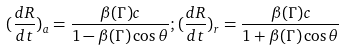Convert formula to latex. <formula><loc_0><loc_0><loc_500><loc_500>( \frac { d R } { d t } ) _ { a } = \frac { \beta ( \Gamma ) c } { 1 - \beta ( \Gamma ) \cos \theta } ; ( \frac { d R } { d t } ) _ { r } = \frac { \beta ( \Gamma ) c } { 1 + \beta ( \Gamma ) \cos \theta }</formula> 